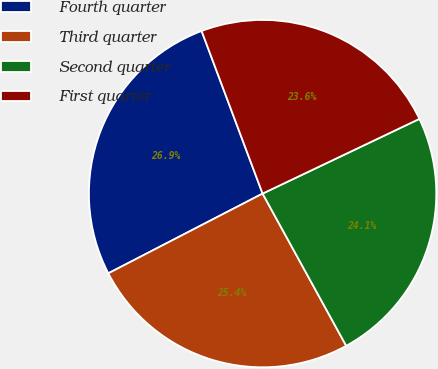Convert chart. <chart><loc_0><loc_0><loc_500><loc_500><pie_chart><fcel>Fourth quarter<fcel>Third quarter<fcel>Second quarter<fcel>First quarter<nl><fcel>26.88%<fcel>25.4%<fcel>24.08%<fcel>23.63%<nl></chart> 